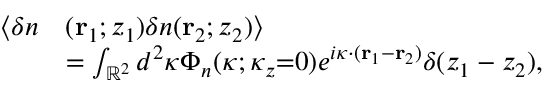Convert formula to latex. <formula><loc_0><loc_0><loc_500><loc_500>\begin{array} { r l } { \langle \delta n } & { ( r _ { 1 } ; z _ { 1 } ) \delta n ( r _ { 2 } ; z _ { 2 } ) \rangle } \\ & { = \int _ { \mathbb { R } ^ { 2 } } d ^ { 2 } \kappa \Phi _ { n } ( \kappa ; \kappa _ { z } { = } 0 ) e ^ { i \kappa \cdot ( r _ { 1 } - r _ { 2 } ) } \delta ( z _ { 1 } - z _ { 2 } ) , } \end{array}</formula> 